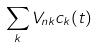<formula> <loc_0><loc_0><loc_500><loc_500>\sum _ { k } V _ { n k } c _ { k } ( t )</formula> 